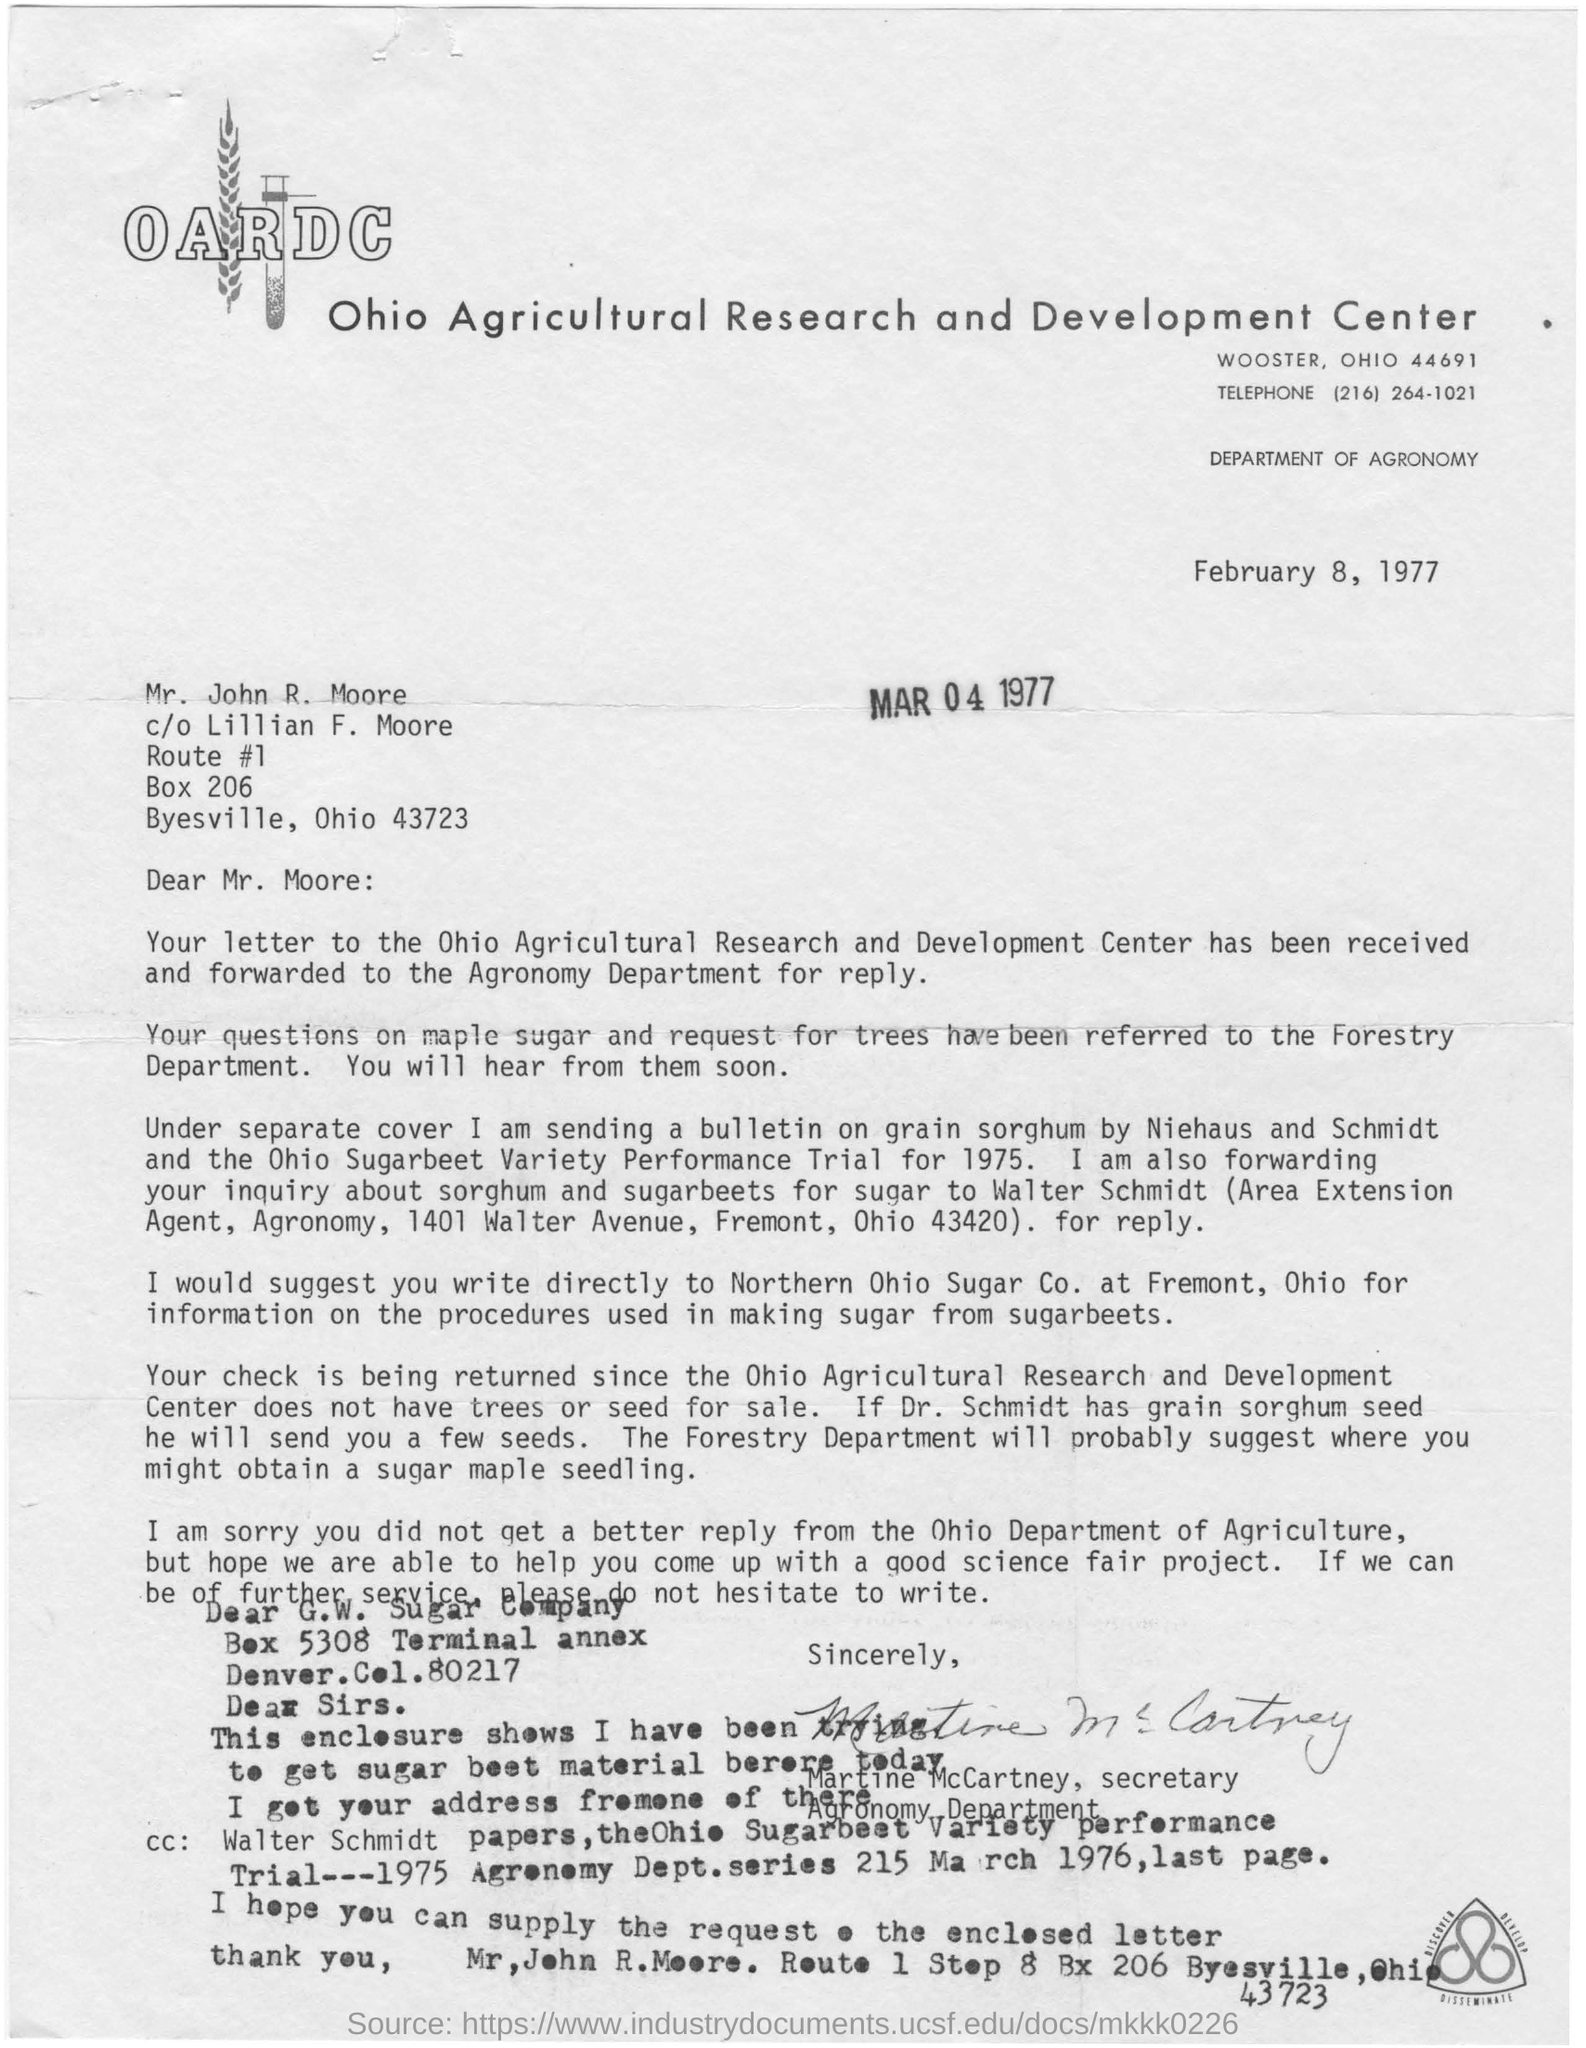What is OARDC ?
Give a very brief answer. Ohio Agricultural research and Development Center. 